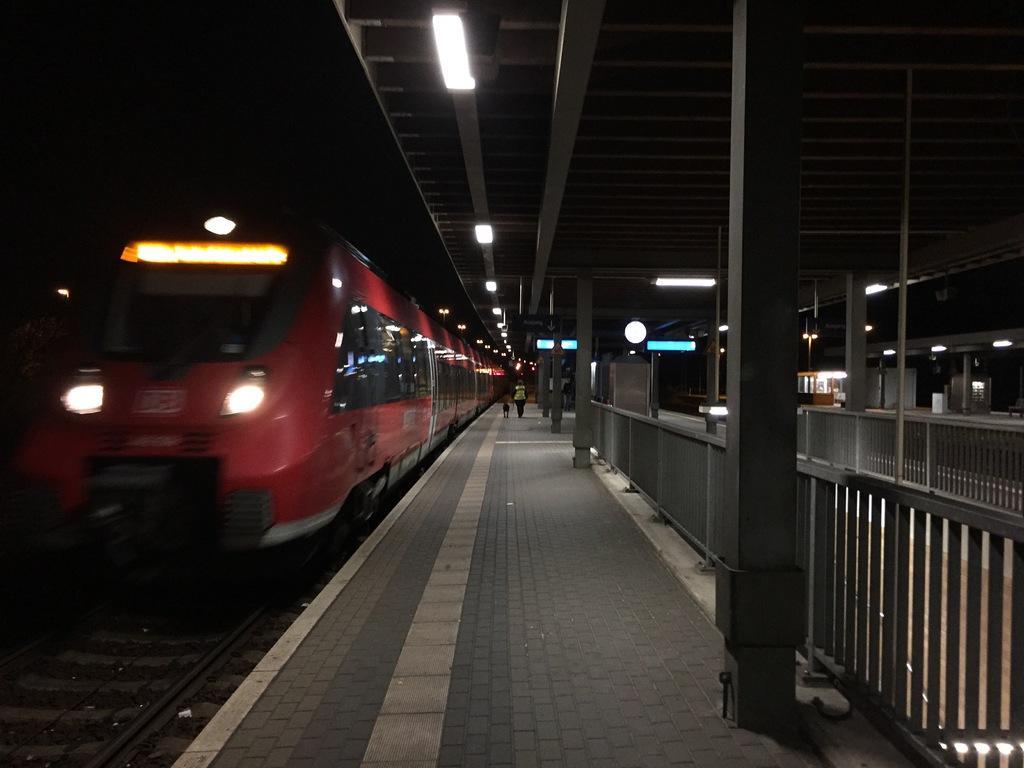Can you describe this image briefly? In the image there is a train on the left side, in the middle there is platform and two persons walking in the background, there are lights over the ceiling. 